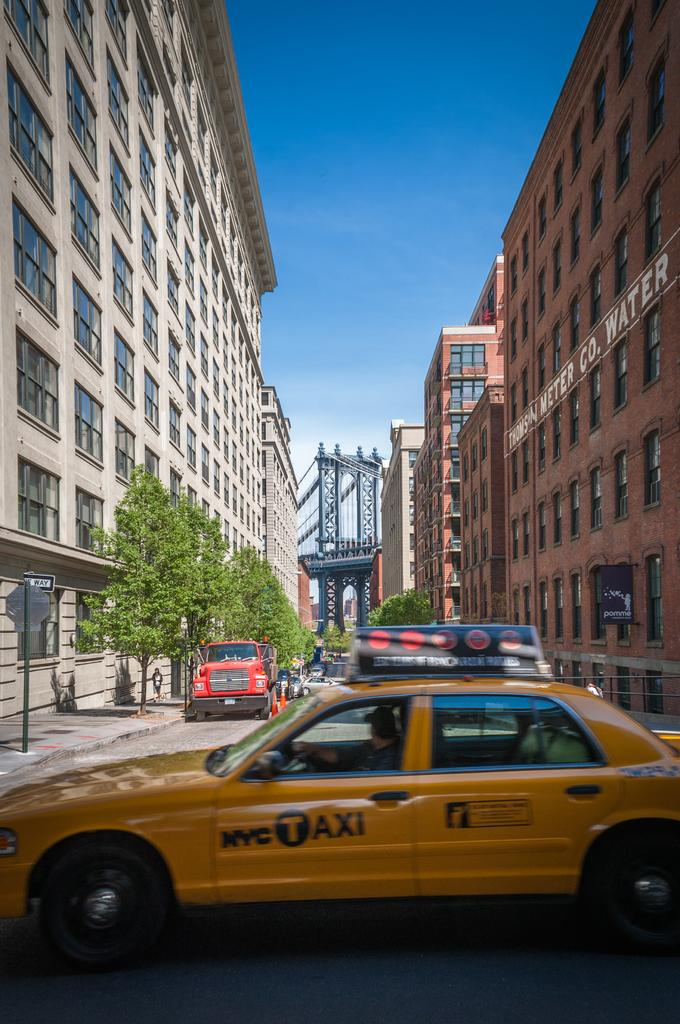<image>
Present a compact description of the photo's key features. A NYC Taxi with tall buildings all around 